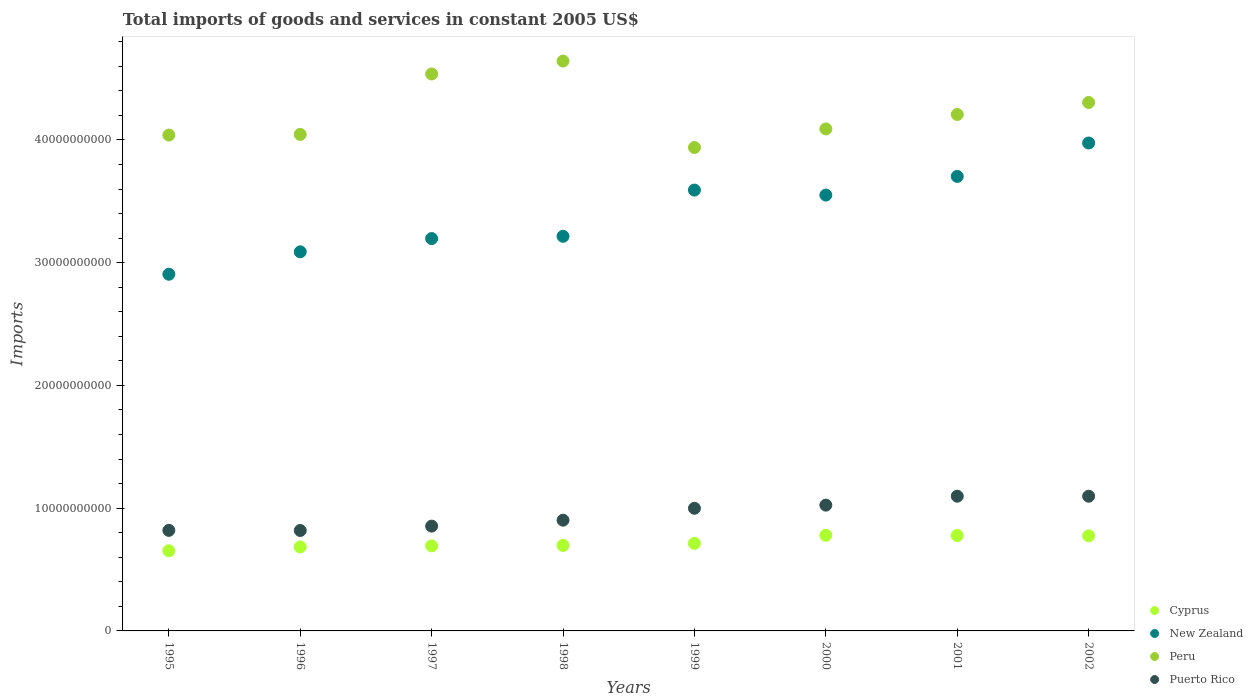How many different coloured dotlines are there?
Give a very brief answer. 4. Is the number of dotlines equal to the number of legend labels?
Keep it short and to the point. Yes. What is the total imports of goods and services in New Zealand in 1998?
Provide a short and direct response. 3.21e+1. Across all years, what is the maximum total imports of goods and services in Cyprus?
Keep it short and to the point. 7.79e+09. Across all years, what is the minimum total imports of goods and services in Peru?
Offer a very short reply. 3.94e+1. What is the total total imports of goods and services in Cyprus in the graph?
Make the answer very short. 5.77e+1. What is the difference between the total imports of goods and services in Cyprus in 1997 and that in 2001?
Give a very brief answer. -8.48e+08. What is the difference between the total imports of goods and services in Cyprus in 2002 and the total imports of goods and services in Puerto Rico in 1995?
Ensure brevity in your answer.  -4.43e+08. What is the average total imports of goods and services in Cyprus per year?
Provide a short and direct response. 7.21e+09. In the year 1997, what is the difference between the total imports of goods and services in Cyprus and total imports of goods and services in Peru?
Provide a short and direct response. -3.84e+1. In how many years, is the total imports of goods and services in New Zealand greater than 26000000000 US$?
Give a very brief answer. 8. What is the ratio of the total imports of goods and services in Cyprus in 1999 to that in 2000?
Give a very brief answer. 0.92. Is the total imports of goods and services in Peru in 1995 less than that in 1999?
Offer a terse response. No. What is the difference between the highest and the second highest total imports of goods and services in Puerto Rico?
Give a very brief answer. 5.59e+05. What is the difference between the highest and the lowest total imports of goods and services in Peru?
Keep it short and to the point. 7.04e+09. Is the sum of the total imports of goods and services in New Zealand in 1998 and 2000 greater than the maximum total imports of goods and services in Cyprus across all years?
Keep it short and to the point. Yes. Is it the case that in every year, the sum of the total imports of goods and services in Cyprus and total imports of goods and services in Puerto Rico  is greater than the total imports of goods and services in New Zealand?
Offer a very short reply. No. Does the total imports of goods and services in Peru monotonically increase over the years?
Offer a terse response. No. Is the total imports of goods and services in Puerto Rico strictly less than the total imports of goods and services in New Zealand over the years?
Give a very brief answer. Yes. How many dotlines are there?
Your answer should be very brief. 4. What is the difference between two consecutive major ticks on the Y-axis?
Give a very brief answer. 1.00e+1. Where does the legend appear in the graph?
Your answer should be compact. Bottom right. How many legend labels are there?
Give a very brief answer. 4. What is the title of the graph?
Offer a terse response. Total imports of goods and services in constant 2005 US$. What is the label or title of the Y-axis?
Make the answer very short. Imports. What is the Imports in Cyprus in 1995?
Ensure brevity in your answer.  6.53e+09. What is the Imports of New Zealand in 1995?
Offer a terse response. 2.91e+1. What is the Imports in Peru in 1995?
Make the answer very short. 4.04e+1. What is the Imports of Puerto Rico in 1995?
Your answer should be very brief. 8.19e+09. What is the Imports of Cyprus in 1996?
Provide a short and direct response. 6.84e+09. What is the Imports in New Zealand in 1996?
Your answer should be compact. 3.09e+1. What is the Imports in Peru in 1996?
Offer a terse response. 4.04e+1. What is the Imports of Puerto Rico in 1996?
Your response must be concise. 8.18e+09. What is the Imports of Cyprus in 1997?
Offer a very short reply. 6.93e+09. What is the Imports in New Zealand in 1997?
Make the answer very short. 3.20e+1. What is the Imports of Peru in 1997?
Offer a very short reply. 4.54e+1. What is the Imports in Puerto Rico in 1997?
Provide a succinct answer. 8.54e+09. What is the Imports in Cyprus in 1998?
Keep it short and to the point. 6.96e+09. What is the Imports in New Zealand in 1998?
Your answer should be compact. 3.21e+1. What is the Imports of Peru in 1998?
Make the answer very short. 4.64e+1. What is the Imports of Puerto Rico in 1998?
Give a very brief answer. 9.02e+09. What is the Imports in Cyprus in 1999?
Offer a terse response. 7.13e+09. What is the Imports in New Zealand in 1999?
Keep it short and to the point. 3.59e+1. What is the Imports in Peru in 1999?
Keep it short and to the point. 3.94e+1. What is the Imports in Puerto Rico in 1999?
Provide a short and direct response. 9.99e+09. What is the Imports of Cyprus in 2000?
Give a very brief answer. 7.79e+09. What is the Imports of New Zealand in 2000?
Make the answer very short. 3.55e+1. What is the Imports in Peru in 2000?
Your answer should be very brief. 4.09e+1. What is the Imports of Puerto Rico in 2000?
Provide a short and direct response. 1.02e+1. What is the Imports of Cyprus in 2001?
Offer a terse response. 7.78e+09. What is the Imports of New Zealand in 2001?
Keep it short and to the point. 3.70e+1. What is the Imports of Peru in 2001?
Your answer should be compact. 4.21e+1. What is the Imports of Puerto Rico in 2001?
Give a very brief answer. 1.10e+1. What is the Imports in Cyprus in 2002?
Your answer should be compact. 7.75e+09. What is the Imports of New Zealand in 2002?
Your response must be concise. 3.97e+1. What is the Imports in Peru in 2002?
Your answer should be very brief. 4.30e+1. What is the Imports of Puerto Rico in 2002?
Your answer should be very brief. 1.10e+1. Across all years, what is the maximum Imports of Cyprus?
Provide a succinct answer. 7.79e+09. Across all years, what is the maximum Imports in New Zealand?
Offer a very short reply. 3.97e+1. Across all years, what is the maximum Imports of Peru?
Your answer should be compact. 4.64e+1. Across all years, what is the maximum Imports of Puerto Rico?
Give a very brief answer. 1.10e+1. Across all years, what is the minimum Imports of Cyprus?
Your response must be concise. 6.53e+09. Across all years, what is the minimum Imports of New Zealand?
Your answer should be very brief. 2.91e+1. Across all years, what is the minimum Imports in Peru?
Provide a succinct answer. 3.94e+1. Across all years, what is the minimum Imports in Puerto Rico?
Keep it short and to the point. 8.18e+09. What is the total Imports in Cyprus in the graph?
Keep it short and to the point. 5.77e+1. What is the total Imports in New Zealand in the graph?
Offer a very short reply. 2.72e+11. What is the total Imports of Peru in the graph?
Offer a terse response. 3.38e+11. What is the total Imports in Puerto Rico in the graph?
Offer a very short reply. 7.61e+1. What is the difference between the Imports in Cyprus in 1995 and that in 1996?
Make the answer very short. -3.12e+08. What is the difference between the Imports of New Zealand in 1995 and that in 1996?
Provide a succinct answer. -1.83e+09. What is the difference between the Imports of Peru in 1995 and that in 1996?
Offer a very short reply. -5.37e+07. What is the difference between the Imports of Puerto Rico in 1995 and that in 1996?
Keep it short and to the point. 9.22e+06. What is the difference between the Imports in Cyprus in 1995 and that in 1997?
Your answer should be compact. -3.96e+08. What is the difference between the Imports in New Zealand in 1995 and that in 1997?
Your response must be concise. -2.91e+09. What is the difference between the Imports of Peru in 1995 and that in 1997?
Your response must be concise. -4.97e+09. What is the difference between the Imports of Puerto Rico in 1995 and that in 1997?
Make the answer very short. -3.47e+08. What is the difference between the Imports of Cyprus in 1995 and that in 1998?
Your answer should be very brief. -4.33e+08. What is the difference between the Imports in New Zealand in 1995 and that in 1998?
Keep it short and to the point. -3.09e+09. What is the difference between the Imports in Peru in 1995 and that in 1998?
Offer a terse response. -6.03e+09. What is the difference between the Imports in Puerto Rico in 1995 and that in 1998?
Give a very brief answer. -8.31e+08. What is the difference between the Imports in Cyprus in 1995 and that in 1999?
Ensure brevity in your answer.  -6.02e+08. What is the difference between the Imports in New Zealand in 1995 and that in 1999?
Offer a terse response. -6.86e+09. What is the difference between the Imports of Peru in 1995 and that in 1999?
Provide a short and direct response. 1.01e+09. What is the difference between the Imports in Puerto Rico in 1995 and that in 1999?
Ensure brevity in your answer.  -1.80e+09. What is the difference between the Imports of Cyprus in 1995 and that in 2000?
Offer a very short reply. -1.26e+09. What is the difference between the Imports in New Zealand in 1995 and that in 2000?
Offer a terse response. -6.45e+09. What is the difference between the Imports in Peru in 1995 and that in 2000?
Provide a succinct answer. -4.97e+08. What is the difference between the Imports of Puerto Rico in 1995 and that in 2000?
Your answer should be compact. -2.06e+09. What is the difference between the Imports of Cyprus in 1995 and that in 2001?
Provide a succinct answer. -1.24e+09. What is the difference between the Imports in New Zealand in 1995 and that in 2001?
Offer a very short reply. -7.97e+09. What is the difference between the Imports in Peru in 1995 and that in 2001?
Give a very brief answer. -1.68e+09. What is the difference between the Imports of Puerto Rico in 1995 and that in 2001?
Ensure brevity in your answer.  -2.78e+09. What is the difference between the Imports in Cyprus in 1995 and that in 2002?
Your response must be concise. -1.22e+09. What is the difference between the Imports in New Zealand in 1995 and that in 2002?
Give a very brief answer. -1.07e+1. What is the difference between the Imports in Peru in 1995 and that in 2002?
Provide a succinct answer. -2.65e+09. What is the difference between the Imports in Puerto Rico in 1995 and that in 2002?
Provide a succinct answer. -2.78e+09. What is the difference between the Imports in Cyprus in 1996 and that in 1997?
Make the answer very short. -8.42e+07. What is the difference between the Imports of New Zealand in 1996 and that in 1997?
Give a very brief answer. -1.08e+09. What is the difference between the Imports of Peru in 1996 and that in 1997?
Make the answer very short. -4.92e+09. What is the difference between the Imports of Puerto Rico in 1996 and that in 1997?
Keep it short and to the point. -3.56e+08. What is the difference between the Imports in Cyprus in 1996 and that in 1998?
Offer a very short reply. -1.21e+08. What is the difference between the Imports of New Zealand in 1996 and that in 1998?
Your answer should be very brief. -1.26e+09. What is the difference between the Imports in Peru in 1996 and that in 1998?
Keep it short and to the point. -5.97e+09. What is the difference between the Imports in Puerto Rico in 1996 and that in 1998?
Your response must be concise. -8.40e+08. What is the difference between the Imports of Cyprus in 1996 and that in 1999?
Give a very brief answer. -2.90e+08. What is the difference between the Imports of New Zealand in 1996 and that in 1999?
Give a very brief answer. -5.03e+09. What is the difference between the Imports of Peru in 1996 and that in 1999?
Keep it short and to the point. 1.07e+09. What is the difference between the Imports of Puerto Rico in 1996 and that in 1999?
Your answer should be compact. -1.81e+09. What is the difference between the Imports in Cyprus in 1996 and that in 2000?
Offer a terse response. -9.48e+08. What is the difference between the Imports of New Zealand in 1996 and that in 2000?
Provide a short and direct response. -4.62e+09. What is the difference between the Imports of Peru in 1996 and that in 2000?
Your answer should be compact. -4.43e+08. What is the difference between the Imports in Puerto Rico in 1996 and that in 2000?
Provide a succinct answer. -2.07e+09. What is the difference between the Imports in Cyprus in 1996 and that in 2001?
Offer a very short reply. -9.33e+08. What is the difference between the Imports of New Zealand in 1996 and that in 2001?
Make the answer very short. -6.14e+09. What is the difference between the Imports in Peru in 1996 and that in 2001?
Give a very brief answer. -1.62e+09. What is the difference between the Imports of Puerto Rico in 1996 and that in 2001?
Give a very brief answer. -2.79e+09. What is the difference between the Imports of Cyprus in 1996 and that in 2002?
Your response must be concise. -9.05e+08. What is the difference between the Imports in New Zealand in 1996 and that in 2002?
Ensure brevity in your answer.  -8.86e+09. What is the difference between the Imports in Peru in 1996 and that in 2002?
Your answer should be compact. -2.60e+09. What is the difference between the Imports in Puerto Rico in 1996 and that in 2002?
Give a very brief answer. -2.79e+09. What is the difference between the Imports in Cyprus in 1997 and that in 1998?
Your response must be concise. -3.70e+07. What is the difference between the Imports in New Zealand in 1997 and that in 1998?
Provide a succinct answer. -1.84e+08. What is the difference between the Imports in Peru in 1997 and that in 1998?
Offer a terse response. -1.05e+09. What is the difference between the Imports of Puerto Rico in 1997 and that in 1998?
Give a very brief answer. -4.84e+08. What is the difference between the Imports of Cyprus in 1997 and that in 1999?
Provide a short and direct response. -2.06e+08. What is the difference between the Imports of New Zealand in 1997 and that in 1999?
Keep it short and to the point. -3.95e+09. What is the difference between the Imports in Peru in 1997 and that in 1999?
Give a very brief answer. 5.99e+09. What is the difference between the Imports in Puerto Rico in 1997 and that in 1999?
Ensure brevity in your answer.  -1.45e+09. What is the difference between the Imports of Cyprus in 1997 and that in 2000?
Your response must be concise. -8.63e+08. What is the difference between the Imports in New Zealand in 1997 and that in 2000?
Offer a terse response. -3.54e+09. What is the difference between the Imports in Peru in 1997 and that in 2000?
Your answer should be compact. 4.48e+09. What is the difference between the Imports in Puerto Rico in 1997 and that in 2000?
Offer a terse response. -1.71e+09. What is the difference between the Imports of Cyprus in 1997 and that in 2001?
Offer a very short reply. -8.48e+08. What is the difference between the Imports in New Zealand in 1997 and that in 2001?
Your response must be concise. -5.06e+09. What is the difference between the Imports of Peru in 1997 and that in 2001?
Your answer should be very brief. 3.30e+09. What is the difference between the Imports of Puerto Rico in 1997 and that in 2001?
Your answer should be very brief. -2.44e+09. What is the difference between the Imports in Cyprus in 1997 and that in 2002?
Your answer should be compact. -8.21e+08. What is the difference between the Imports of New Zealand in 1997 and that in 2002?
Provide a succinct answer. -7.78e+09. What is the difference between the Imports of Peru in 1997 and that in 2002?
Offer a terse response. 2.32e+09. What is the difference between the Imports of Puerto Rico in 1997 and that in 2002?
Offer a terse response. -2.44e+09. What is the difference between the Imports in Cyprus in 1998 and that in 1999?
Provide a succinct answer. -1.69e+08. What is the difference between the Imports of New Zealand in 1998 and that in 1999?
Ensure brevity in your answer.  -3.77e+09. What is the difference between the Imports in Peru in 1998 and that in 1999?
Give a very brief answer. 7.04e+09. What is the difference between the Imports in Puerto Rico in 1998 and that in 1999?
Provide a succinct answer. -9.69e+08. What is the difference between the Imports in Cyprus in 1998 and that in 2000?
Keep it short and to the point. -8.26e+08. What is the difference between the Imports of New Zealand in 1998 and that in 2000?
Give a very brief answer. -3.36e+09. What is the difference between the Imports of Peru in 1998 and that in 2000?
Provide a succinct answer. 5.53e+09. What is the difference between the Imports of Puerto Rico in 1998 and that in 2000?
Provide a succinct answer. -1.23e+09. What is the difference between the Imports of Cyprus in 1998 and that in 2001?
Ensure brevity in your answer.  -8.11e+08. What is the difference between the Imports in New Zealand in 1998 and that in 2001?
Your response must be concise. -4.88e+09. What is the difference between the Imports in Peru in 1998 and that in 2001?
Offer a terse response. 4.35e+09. What is the difference between the Imports of Puerto Rico in 1998 and that in 2001?
Make the answer very short. -1.95e+09. What is the difference between the Imports in Cyprus in 1998 and that in 2002?
Your response must be concise. -7.84e+08. What is the difference between the Imports of New Zealand in 1998 and that in 2002?
Provide a succinct answer. -7.60e+09. What is the difference between the Imports in Peru in 1998 and that in 2002?
Ensure brevity in your answer.  3.37e+09. What is the difference between the Imports of Puerto Rico in 1998 and that in 2002?
Offer a very short reply. -1.95e+09. What is the difference between the Imports in Cyprus in 1999 and that in 2000?
Offer a terse response. -6.57e+08. What is the difference between the Imports of New Zealand in 1999 and that in 2000?
Your answer should be compact. 4.07e+08. What is the difference between the Imports in Peru in 1999 and that in 2000?
Your response must be concise. -1.51e+09. What is the difference between the Imports in Puerto Rico in 1999 and that in 2000?
Your answer should be compact. -2.56e+08. What is the difference between the Imports of Cyprus in 1999 and that in 2001?
Offer a very short reply. -6.42e+08. What is the difference between the Imports of New Zealand in 1999 and that in 2001?
Provide a short and direct response. -1.11e+09. What is the difference between the Imports of Peru in 1999 and that in 2001?
Offer a terse response. -2.69e+09. What is the difference between the Imports of Puerto Rico in 1999 and that in 2001?
Your answer should be compact. -9.85e+08. What is the difference between the Imports of Cyprus in 1999 and that in 2002?
Ensure brevity in your answer.  -6.15e+08. What is the difference between the Imports in New Zealand in 1999 and that in 2002?
Your answer should be very brief. -3.83e+09. What is the difference between the Imports in Peru in 1999 and that in 2002?
Ensure brevity in your answer.  -3.67e+09. What is the difference between the Imports in Puerto Rico in 1999 and that in 2002?
Make the answer very short. -9.84e+08. What is the difference between the Imports in Cyprus in 2000 and that in 2001?
Your response must be concise. 1.49e+07. What is the difference between the Imports in New Zealand in 2000 and that in 2001?
Your answer should be very brief. -1.52e+09. What is the difference between the Imports of Peru in 2000 and that in 2001?
Your answer should be compact. -1.18e+09. What is the difference between the Imports in Puerto Rico in 2000 and that in 2001?
Keep it short and to the point. -7.28e+08. What is the difference between the Imports of Cyprus in 2000 and that in 2002?
Keep it short and to the point. 4.27e+07. What is the difference between the Imports in New Zealand in 2000 and that in 2002?
Keep it short and to the point. -4.24e+09. What is the difference between the Imports of Peru in 2000 and that in 2002?
Your response must be concise. -2.16e+09. What is the difference between the Imports in Puerto Rico in 2000 and that in 2002?
Make the answer very short. -7.27e+08. What is the difference between the Imports of Cyprus in 2001 and that in 2002?
Offer a very short reply. 2.78e+07. What is the difference between the Imports of New Zealand in 2001 and that in 2002?
Provide a short and direct response. -2.72e+09. What is the difference between the Imports of Peru in 2001 and that in 2002?
Make the answer very short. -9.76e+08. What is the difference between the Imports in Puerto Rico in 2001 and that in 2002?
Ensure brevity in your answer.  5.59e+05. What is the difference between the Imports of Cyprus in 1995 and the Imports of New Zealand in 1996?
Ensure brevity in your answer.  -2.44e+1. What is the difference between the Imports in Cyprus in 1995 and the Imports in Peru in 1996?
Give a very brief answer. -3.39e+1. What is the difference between the Imports of Cyprus in 1995 and the Imports of Puerto Rico in 1996?
Ensure brevity in your answer.  -1.65e+09. What is the difference between the Imports in New Zealand in 1995 and the Imports in Peru in 1996?
Your answer should be compact. -1.14e+1. What is the difference between the Imports in New Zealand in 1995 and the Imports in Puerto Rico in 1996?
Offer a very short reply. 2.09e+1. What is the difference between the Imports of Peru in 1995 and the Imports of Puerto Rico in 1996?
Keep it short and to the point. 3.22e+1. What is the difference between the Imports in Cyprus in 1995 and the Imports in New Zealand in 1997?
Ensure brevity in your answer.  -2.54e+1. What is the difference between the Imports of Cyprus in 1995 and the Imports of Peru in 1997?
Make the answer very short. -3.88e+1. What is the difference between the Imports of Cyprus in 1995 and the Imports of Puerto Rico in 1997?
Offer a very short reply. -2.01e+09. What is the difference between the Imports in New Zealand in 1995 and the Imports in Peru in 1997?
Ensure brevity in your answer.  -1.63e+1. What is the difference between the Imports in New Zealand in 1995 and the Imports in Puerto Rico in 1997?
Ensure brevity in your answer.  2.05e+1. What is the difference between the Imports in Peru in 1995 and the Imports in Puerto Rico in 1997?
Give a very brief answer. 3.19e+1. What is the difference between the Imports of Cyprus in 1995 and the Imports of New Zealand in 1998?
Your answer should be very brief. -2.56e+1. What is the difference between the Imports in Cyprus in 1995 and the Imports in Peru in 1998?
Your response must be concise. -3.99e+1. What is the difference between the Imports in Cyprus in 1995 and the Imports in Puerto Rico in 1998?
Make the answer very short. -2.49e+09. What is the difference between the Imports of New Zealand in 1995 and the Imports of Peru in 1998?
Make the answer very short. -1.74e+1. What is the difference between the Imports in New Zealand in 1995 and the Imports in Puerto Rico in 1998?
Your answer should be compact. 2.00e+1. What is the difference between the Imports of Peru in 1995 and the Imports of Puerto Rico in 1998?
Make the answer very short. 3.14e+1. What is the difference between the Imports of Cyprus in 1995 and the Imports of New Zealand in 1999?
Your answer should be compact. -2.94e+1. What is the difference between the Imports in Cyprus in 1995 and the Imports in Peru in 1999?
Make the answer very short. -3.29e+1. What is the difference between the Imports of Cyprus in 1995 and the Imports of Puerto Rico in 1999?
Ensure brevity in your answer.  -3.46e+09. What is the difference between the Imports in New Zealand in 1995 and the Imports in Peru in 1999?
Provide a succinct answer. -1.03e+1. What is the difference between the Imports of New Zealand in 1995 and the Imports of Puerto Rico in 1999?
Provide a short and direct response. 1.91e+1. What is the difference between the Imports in Peru in 1995 and the Imports in Puerto Rico in 1999?
Your response must be concise. 3.04e+1. What is the difference between the Imports in Cyprus in 1995 and the Imports in New Zealand in 2000?
Ensure brevity in your answer.  -2.90e+1. What is the difference between the Imports of Cyprus in 1995 and the Imports of Peru in 2000?
Ensure brevity in your answer.  -3.44e+1. What is the difference between the Imports in Cyprus in 1995 and the Imports in Puerto Rico in 2000?
Make the answer very short. -3.72e+09. What is the difference between the Imports of New Zealand in 1995 and the Imports of Peru in 2000?
Ensure brevity in your answer.  -1.18e+1. What is the difference between the Imports of New Zealand in 1995 and the Imports of Puerto Rico in 2000?
Ensure brevity in your answer.  1.88e+1. What is the difference between the Imports in Peru in 1995 and the Imports in Puerto Rico in 2000?
Make the answer very short. 3.01e+1. What is the difference between the Imports in Cyprus in 1995 and the Imports in New Zealand in 2001?
Offer a terse response. -3.05e+1. What is the difference between the Imports in Cyprus in 1995 and the Imports in Peru in 2001?
Your response must be concise. -3.55e+1. What is the difference between the Imports of Cyprus in 1995 and the Imports of Puerto Rico in 2001?
Your answer should be very brief. -4.44e+09. What is the difference between the Imports of New Zealand in 1995 and the Imports of Peru in 2001?
Offer a very short reply. -1.30e+1. What is the difference between the Imports of New Zealand in 1995 and the Imports of Puerto Rico in 2001?
Give a very brief answer. 1.81e+1. What is the difference between the Imports in Peru in 1995 and the Imports in Puerto Rico in 2001?
Keep it short and to the point. 2.94e+1. What is the difference between the Imports in Cyprus in 1995 and the Imports in New Zealand in 2002?
Keep it short and to the point. -3.32e+1. What is the difference between the Imports of Cyprus in 1995 and the Imports of Peru in 2002?
Offer a terse response. -3.65e+1. What is the difference between the Imports of Cyprus in 1995 and the Imports of Puerto Rico in 2002?
Offer a terse response. -4.44e+09. What is the difference between the Imports in New Zealand in 1995 and the Imports in Peru in 2002?
Your answer should be very brief. -1.40e+1. What is the difference between the Imports in New Zealand in 1995 and the Imports in Puerto Rico in 2002?
Keep it short and to the point. 1.81e+1. What is the difference between the Imports in Peru in 1995 and the Imports in Puerto Rico in 2002?
Make the answer very short. 2.94e+1. What is the difference between the Imports in Cyprus in 1996 and the Imports in New Zealand in 1997?
Offer a very short reply. -2.51e+1. What is the difference between the Imports in Cyprus in 1996 and the Imports in Peru in 1997?
Provide a succinct answer. -3.85e+1. What is the difference between the Imports of Cyprus in 1996 and the Imports of Puerto Rico in 1997?
Your response must be concise. -1.70e+09. What is the difference between the Imports of New Zealand in 1996 and the Imports of Peru in 1997?
Make the answer very short. -1.45e+1. What is the difference between the Imports in New Zealand in 1996 and the Imports in Puerto Rico in 1997?
Provide a succinct answer. 2.23e+1. What is the difference between the Imports of Peru in 1996 and the Imports of Puerto Rico in 1997?
Offer a terse response. 3.19e+1. What is the difference between the Imports in Cyprus in 1996 and the Imports in New Zealand in 1998?
Keep it short and to the point. -2.53e+1. What is the difference between the Imports in Cyprus in 1996 and the Imports in Peru in 1998?
Provide a short and direct response. -3.96e+1. What is the difference between the Imports of Cyprus in 1996 and the Imports of Puerto Rico in 1998?
Make the answer very short. -2.18e+09. What is the difference between the Imports of New Zealand in 1996 and the Imports of Peru in 1998?
Make the answer very short. -1.55e+1. What is the difference between the Imports of New Zealand in 1996 and the Imports of Puerto Rico in 1998?
Your response must be concise. 2.19e+1. What is the difference between the Imports in Peru in 1996 and the Imports in Puerto Rico in 1998?
Offer a terse response. 3.14e+1. What is the difference between the Imports of Cyprus in 1996 and the Imports of New Zealand in 1999?
Your answer should be compact. -2.91e+1. What is the difference between the Imports of Cyprus in 1996 and the Imports of Peru in 1999?
Provide a succinct answer. -3.25e+1. What is the difference between the Imports of Cyprus in 1996 and the Imports of Puerto Rico in 1999?
Provide a succinct answer. -3.15e+09. What is the difference between the Imports in New Zealand in 1996 and the Imports in Peru in 1999?
Your response must be concise. -8.50e+09. What is the difference between the Imports of New Zealand in 1996 and the Imports of Puerto Rico in 1999?
Your response must be concise. 2.09e+1. What is the difference between the Imports of Peru in 1996 and the Imports of Puerto Rico in 1999?
Give a very brief answer. 3.05e+1. What is the difference between the Imports of Cyprus in 1996 and the Imports of New Zealand in 2000?
Provide a succinct answer. -2.87e+1. What is the difference between the Imports of Cyprus in 1996 and the Imports of Peru in 2000?
Ensure brevity in your answer.  -3.41e+1. What is the difference between the Imports of Cyprus in 1996 and the Imports of Puerto Rico in 2000?
Provide a short and direct response. -3.40e+09. What is the difference between the Imports of New Zealand in 1996 and the Imports of Peru in 2000?
Provide a short and direct response. -1.00e+1. What is the difference between the Imports of New Zealand in 1996 and the Imports of Puerto Rico in 2000?
Ensure brevity in your answer.  2.06e+1. What is the difference between the Imports in Peru in 1996 and the Imports in Puerto Rico in 2000?
Your response must be concise. 3.02e+1. What is the difference between the Imports of Cyprus in 1996 and the Imports of New Zealand in 2001?
Your response must be concise. -3.02e+1. What is the difference between the Imports in Cyprus in 1996 and the Imports in Peru in 2001?
Make the answer very short. -3.52e+1. What is the difference between the Imports in Cyprus in 1996 and the Imports in Puerto Rico in 2001?
Offer a very short reply. -4.13e+09. What is the difference between the Imports of New Zealand in 1996 and the Imports of Peru in 2001?
Provide a succinct answer. -1.12e+1. What is the difference between the Imports in New Zealand in 1996 and the Imports in Puerto Rico in 2001?
Your answer should be very brief. 1.99e+1. What is the difference between the Imports of Peru in 1996 and the Imports of Puerto Rico in 2001?
Make the answer very short. 2.95e+1. What is the difference between the Imports in Cyprus in 1996 and the Imports in New Zealand in 2002?
Your answer should be very brief. -3.29e+1. What is the difference between the Imports in Cyprus in 1996 and the Imports in Peru in 2002?
Provide a short and direct response. -3.62e+1. What is the difference between the Imports in Cyprus in 1996 and the Imports in Puerto Rico in 2002?
Offer a very short reply. -4.13e+09. What is the difference between the Imports in New Zealand in 1996 and the Imports in Peru in 2002?
Offer a very short reply. -1.22e+1. What is the difference between the Imports of New Zealand in 1996 and the Imports of Puerto Rico in 2002?
Ensure brevity in your answer.  1.99e+1. What is the difference between the Imports in Peru in 1996 and the Imports in Puerto Rico in 2002?
Give a very brief answer. 2.95e+1. What is the difference between the Imports of Cyprus in 1997 and the Imports of New Zealand in 1998?
Make the answer very short. -2.52e+1. What is the difference between the Imports of Cyprus in 1997 and the Imports of Peru in 1998?
Ensure brevity in your answer.  -3.95e+1. What is the difference between the Imports in Cyprus in 1997 and the Imports in Puerto Rico in 1998?
Offer a very short reply. -2.10e+09. What is the difference between the Imports in New Zealand in 1997 and the Imports in Peru in 1998?
Your answer should be very brief. -1.45e+1. What is the difference between the Imports of New Zealand in 1997 and the Imports of Puerto Rico in 1998?
Offer a very short reply. 2.29e+1. What is the difference between the Imports of Peru in 1997 and the Imports of Puerto Rico in 1998?
Provide a short and direct response. 3.63e+1. What is the difference between the Imports of Cyprus in 1997 and the Imports of New Zealand in 1999?
Your answer should be very brief. -2.90e+1. What is the difference between the Imports in Cyprus in 1997 and the Imports in Peru in 1999?
Ensure brevity in your answer.  -3.25e+1. What is the difference between the Imports of Cyprus in 1997 and the Imports of Puerto Rico in 1999?
Make the answer very short. -3.06e+09. What is the difference between the Imports in New Zealand in 1997 and the Imports in Peru in 1999?
Give a very brief answer. -7.42e+09. What is the difference between the Imports in New Zealand in 1997 and the Imports in Puerto Rico in 1999?
Your answer should be compact. 2.20e+1. What is the difference between the Imports in Peru in 1997 and the Imports in Puerto Rico in 1999?
Offer a very short reply. 3.54e+1. What is the difference between the Imports of Cyprus in 1997 and the Imports of New Zealand in 2000?
Provide a short and direct response. -2.86e+1. What is the difference between the Imports in Cyprus in 1997 and the Imports in Peru in 2000?
Offer a very short reply. -3.40e+1. What is the difference between the Imports in Cyprus in 1997 and the Imports in Puerto Rico in 2000?
Offer a very short reply. -3.32e+09. What is the difference between the Imports of New Zealand in 1997 and the Imports of Peru in 2000?
Provide a succinct answer. -8.93e+09. What is the difference between the Imports in New Zealand in 1997 and the Imports in Puerto Rico in 2000?
Keep it short and to the point. 2.17e+1. What is the difference between the Imports of Peru in 1997 and the Imports of Puerto Rico in 2000?
Your answer should be very brief. 3.51e+1. What is the difference between the Imports in Cyprus in 1997 and the Imports in New Zealand in 2001?
Provide a short and direct response. -3.01e+1. What is the difference between the Imports of Cyprus in 1997 and the Imports of Peru in 2001?
Your answer should be compact. -3.51e+1. What is the difference between the Imports of Cyprus in 1997 and the Imports of Puerto Rico in 2001?
Provide a succinct answer. -4.05e+09. What is the difference between the Imports of New Zealand in 1997 and the Imports of Peru in 2001?
Provide a succinct answer. -1.01e+1. What is the difference between the Imports in New Zealand in 1997 and the Imports in Puerto Rico in 2001?
Your answer should be very brief. 2.10e+1. What is the difference between the Imports in Peru in 1997 and the Imports in Puerto Rico in 2001?
Your answer should be very brief. 3.44e+1. What is the difference between the Imports in Cyprus in 1997 and the Imports in New Zealand in 2002?
Offer a very short reply. -3.28e+1. What is the difference between the Imports in Cyprus in 1997 and the Imports in Peru in 2002?
Offer a terse response. -3.61e+1. What is the difference between the Imports of Cyprus in 1997 and the Imports of Puerto Rico in 2002?
Your answer should be compact. -4.05e+09. What is the difference between the Imports in New Zealand in 1997 and the Imports in Peru in 2002?
Ensure brevity in your answer.  -1.11e+1. What is the difference between the Imports in New Zealand in 1997 and the Imports in Puerto Rico in 2002?
Provide a short and direct response. 2.10e+1. What is the difference between the Imports in Peru in 1997 and the Imports in Puerto Rico in 2002?
Give a very brief answer. 3.44e+1. What is the difference between the Imports of Cyprus in 1998 and the Imports of New Zealand in 1999?
Make the answer very short. -2.89e+1. What is the difference between the Imports of Cyprus in 1998 and the Imports of Peru in 1999?
Make the answer very short. -3.24e+1. What is the difference between the Imports in Cyprus in 1998 and the Imports in Puerto Rico in 1999?
Keep it short and to the point. -3.03e+09. What is the difference between the Imports of New Zealand in 1998 and the Imports of Peru in 1999?
Ensure brevity in your answer.  -7.23e+09. What is the difference between the Imports of New Zealand in 1998 and the Imports of Puerto Rico in 1999?
Provide a short and direct response. 2.22e+1. What is the difference between the Imports of Peru in 1998 and the Imports of Puerto Rico in 1999?
Your answer should be very brief. 3.64e+1. What is the difference between the Imports of Cyprus in 1998 and the Imports of New Zealand in 2000?
Give a very brief answer. -2.85e+1. What is the difference between the Imports of Cyprus in 1998 and the Imports of Peru in 2000?
Provide a succinct answer. -3.39e+1. What is the difference between the Imports of Cyprus in 1998 and the Imports of Puerto Rico in 2000?
Offer a terse response. -3.28e+09. What is the difference between the Imports in New Zealand in 1998 and the Imports in Peru in 2000?
Make the answer very short. -8.75e+09. What is the difference between the Imports of New Zealand in 1998 and the Imports of Puerto Rico in 2000?
Provide a succinct answer. 2.19e+1. What is the difference between the Imports in Peru in 1998 and the Imports in Puerto Rico in 2000?
Provide a short and direct response. 3.62e+1. What is the difference between the Imports in Cyprus in 1998 and the Imports in New Zealand in 2001?
Offer a very short reply. -3.01e+1. What is the difference between the Imports of Cyprus in 1998 and the Imports of Peru in 2001?
Provide a succinct answer. -3.51e+1. What is the difference between the Imports in Cyprus in 1998 and the Imports in Puerto Rico in 2001?
Make the answer very short. -4.01e+09. What is the difference between the Imports of New Zealand in 1998 and the Imports of Peru in 2001?
Offer a terse response. -9.93e+09. What is the difference between the Imports in New Zealand in 1998 and the Imports in Puerto Rico in 2001?
Your answer should be very brief. 2.12e+1. What is the difference between the Imports in Peru in 1998 and the Imports in Puerto Rico in 2001?
Offer a terse response. 3.54e+1. What is the difference between the Imports in Cyprus in 1998 and the Imports in New Zealand in 2002?
Ensure brevity in your answer.  -3.28e+1. What is the difference between the Imports of Cyprus in 1998 and the Imports of Peru in 2002?
Provide a short and direct response. -3.61e+1. What is the difference between the Imports of Cyprus in 1998 and the Imports of Puerto Rico in 2002?
Give a very brief answer. -4.01e+09. What is the difference between the Imports of New Zealand in 1998 and the Imports of Peru in 2002?
Provide a short and direct response. -1.09e+1. What is the difference between the Imports of New Zealand in 1998 and the Imports of Puerto Rico in 2002?
Provide a succinct answer. 2.12e+1. What is the difference between the Imports in Peru in 1998 and the Imports in Puerto Rico in 2002?
Your answer should be compact. 3.54e+1. What is the difference between the Imports of Cyprus in 1999 and the Imports of New Zealand in 2000?
Give a very brief answer. -2.84e+1. What is the difference between the Imports in Cyprus in 1999 and the Imports in Peru in 2000?
Offer a terse response. -3.38e+1. What is the difference between the Imports of Cyprus in 1999 and the Imports of Puerto Rico in 2000?
Provide a succinct answer. -3.11e+09. What is the difference between the Imports of New Zealand in 1999 and the Imports of Peru in 2000?
Give a very brief answer. -4.98e+09. What is the difference between the Imports in New Zealand in 1999 and the Imports in Puerto Rico in 2000?
Your answer should be compact. 2.57e+1. What is the difference between the Imports of Peru in 1999 and the Imports of Puerto Rico in 2000?
Your answer should be very brief. 2.91e+1. What is the difference between the Imports in Cyprus in 1999 and the Imports in New Zealand in 2001?
Ensure brevity in your answer.  -2.99e+1. What is the difference between the Imports of Cyprus in 1999 and the Imports of Peru in 2001?
Offer a terse response. -3.49e+1. What is the difference between the Imports of Cyprus in 1999 and the Imports of Puerto Rico in 2001?
Give a very brief answer. -3.84e+09. What is the difference between the Imports in New Zealand in 1999 and the Imports in Peru in 2001?
Provide a short and direct response. -6.16e+09. What is the difference between the Imports of New Zealand in 1999 and the Imports of Puerto Rico in 2001?
Keep it short and to the point. 2.49e+1. What is the difference between the Imports of Peru in 1999 and the Imports of Puerto Rico in 2001?
Offer a terse response. 2.84e+1. What is the difference between the Imports in Cyprus in 1999 and the Imports in New Zealand in 2002?
Make the answer very short. -3.26e+1. What is the difference between the Imports in Cyprus in 1999 and the Imports in Peru in 2002?
Offer a terse response. -3.59e+1. What is the difference between the Imports of Cyprus in 1999 and the Imports of Puerto Rico in 2002?
Your answer should be compact. -3.84e+09. What is the difference between the Imports in New Zealand in 1999 and the Imports in Peru in 2002?
Give a very brief answer. -7.14e+09. What is the difference between the Imports in New Zealand in 1999 and the Imports in Puerto Rico in 2002?
Make the answer very short. 2.49e+1. What is the difference between the Imports of Peru in 1999 and the Imports of Puerto Rico in 2002?
Your answer should be compact. 2.84e+1. What is the difference between the Imports of Cyprus in 2000 and the Imports of New Zealand in 2001?
Ensure brevity in your answer.  -2.92e+1. What is the difference between the Imports of Cyprus in 2000 and the Imports of Peru in 2001?
Offer a very short reply. -3.43e+1. What is the difference between the Imports in Cyprus in 2000 and the Imports in Puerto Rico in 2001?
Ensure brevity in your answer.  -3.19e+09. What is the difference between the Imports in New Zealand in 2000 and the Imports in Peru in 2001?
Give a very brief answer. -6.57e+09. What is the difference between the Imports of New Zealand in 2000 and the Imports of Puerto Rico in 2001?
Give a very brief answer. 2.45e+1. What is the difference between the Imports of Peru in 2000 and the Imports of Puerto Rico in 2001?
Give a very brief answer. 2.99e+1. What is the difference between the Imports of Cyprus in 2000 and the Imports of New Zealand in 2002?
Your response must be concise. -3.20e+1. What is the difference between the Imports of Cyprus in 2000 and the Imports of Peru in 2002?
Give a very brief answer. -3.53e+1. What is the difference between the Imports in Cyprus in 2000 and the Imports in Puerto Rico in 2002?
Give a very brief answer. -3.18e+09. What is the difference between the Imports of New Zealand in 2000 and the Imports of Peru in 2002?
Make the answer very short. -7.54e+09. What is the difference between the Imports of New Zealand in 2000 and the Imports of Puerto Rico in 2002?
Offer a very short reply. 2.45e+1. What is the difference between the Imports in Peru in 2000 and the Imports in Puerto Rico in 2002?
Give a very brief answer. 2.99e+1. What is the difference between the Imports in Cyprus in 2001 and the Imports in New Zealand in 2002?
Offer a very short reply. -3.20e+1. What is the difference between the Imports in Cyprus in 2001 and the Imports in Peru in 2002?
Your answer should be very brief. -3.53e+1. What is the difference between the Imports in Cyprus in 2001 and the Imports in Puerto Rico in 2002?
Keep it short and to the point. -3.20e+09. What is the difference between the Imports of New Zealand in 2001 and the Imports of Peru in 2002?
Your response must be concise. -6.02e+09. What is the difference between the Imports in New Zealand in 2001 and the Imports in Puerto Rico in 2002?
Offer a terse response. 2.61e+1. What is the difference between the Imports in Peru in 2001 and the Imports in Puerto Rico in 2002?
Provide a short and direct response. 3.11e+1. What is the average Imports in Cyprus per year?
Make the answer very short. 7.21e+09. What is the average Imports in New Zealand per year?
Make the answer very short. 3.40e+1. What is the average Imports in Peru per year?
Give a very brief answer. 4.23e+1. What is the average Imports of Puerto Rico per year?
Provide a succinct answer. 9.52e+09. In the year 1995, what is the difference between the Imports in Cyprus and Imports in New Zealand?
Ensure brevity in your answer.  -2.25e+1. In the year 1995, what is the difference between the Imports in Cyprus and Imports in Peru?
Ensure brevity in your answer.  -3.39e+1. In the year 1995, what is the difference between the Imports of Cyprus and Imports of Puerto Rico?
Offer a terse response. -1.66e+09. In the year 1995, what is the difference between the Imports in New Zealand and Imports in Peru?
Provide a succinct answer. -1.13e+1. In the year 1995, what is the difference between the Imports of New Zealand and Imports of Puerto Rico?
Provide a succinct answer. 2.09e+1. In the year 1995, what is the difference between the Imports in Peru and Imports in Puerto Rico?
Make the answer very short. 3.22e+1. In the year 1996, what is the difference between the Imports of Cyprus and Imports of New Zealand?
Your answer should be compact. -2.40e+1. In the year 1996, what is the difference between the Imports in Cyprus and Imports in Peru?
Provide a short and direct response. -3.36e+1. In the year 1996, what is the difference between the Imports in Cyprus and Imports in Puerto Rico?
Keep it short and to the point. -1.34e+09. In the year 1996, what is the difference between the Imports in New Zealand and Imports in Peru?
Your answer should be very brief. -9.57e+09. In the year 1996, what is the difference between the Imports of New Zealand and Imports of Puerto Rico?
Provide a short and direct response. 2.27e+1. In the year 1996, what is the difference between the Imports in Peru and Imports in Puerto Rico?
Keep it short and to the point. 3.23e+1. In the year 1997, what is the difference between the Imports of Cyprus and Imports of New Zealand?
Your answer should be compact. -2.50e+1. In the year 1997, what is the difference between the Imports of Cyprus and Imports of Peru?
Ensure brevity in your answer.  -3.84e+1. In the year 1997, what is the difference between the Imports in Cyprus and Imports in Puerto Rico?
Offer a very short reply. -1.61e+09. In the year 1997, what is the difference between the Imports in New Zealand and Imports in Peru?
Provide a succinct answer. -1.34e+1. In the year 1997, what is the difference between the Imports in New Zealand and Imports in Puerto Rico?
Provide a short and direct response. 2.34e+1. In the year 1997, what is the difference between the Imports in Peru and Imports in Puerto Rico?
Your answer should be compact. 3.68e+1. In the year 1998, what is the difference between the Imports in Cyprus and Imports in New Zealand?
Give a very brief answer. -2.52e+1. In the year 1998, what is the difference between the Imports in Cyprus and Imports in Peru?
Offer a very short reply. -3.95e+1. In the year 1998, what is the difference between the Imports in Cyprus and Imports in Puerto Rico?
Provide a succinct answer. -2.06e+09. In the year 1998, what is the difference between the Imports in New Zealand and Imports in Peru?
Your answer should be compact. -1.43e+1. In the year 1998, what is the difference between the Imports in New Zealand and Imports in Puerto Rico?
Your answer should be very brief. 2.31e+1. In the year 1998, what is the difference between the Imports of Peru and Imports of Puerto Rico?
Ensure brevity in your answer.  3.74e+1. In the year 1999, what is the difference between the Imports of Cyprus and Imports of New Zealand?
Your answer should be compact. -2.88e+1. In the year 1999, what is the difference between the Imports in Cyprus and Imports in Peru?
Provide a succinct answer. -3.22e+1. In the year 1999, what is the difference between the Imports of Cyprus and Imports of Puerto Rico?
Offer a terse response. -2.86e+09. In the year 1999, what is the difference between the Imports in New Zealand and Imports in Peru?
Your answer should be compact. -3.47e+09. In the year 1999, what is the difference between the Imports in New Zealand and Imports in Puerto Rico?
Keep it short and to the point. 2.59e+1. In the year 1999, what is the difference between the Imports in Peru and Imports in Puerto Rico?
Ensure brevity in your answer.  2.94e+1. In the year 2000, what is the difference between the Imports of Cyprus and Imports of New Zealand?
Your answer should be very brief. -2.77e+1. In the year 2000, what is the difference between the Imports of Cyprus and Imports of Peru?
Make the answer very short. -3.31e+1. In the year 2000, what is the difference between the Imports of Cyprus and Imports of Puerto Rico?
Offer a terse response. -2.46e+09. In the year 2000, what is the difference between the Imports of New Zealand and Imports of Peru?
Provide a short and direct response. -5.39e+09. In the year 2000, what is the difference between the Imports in New Zealand and Imports in Puerto Rico?
Offer a very short reply. 2.53e+1. In the year 2000, what is the difference between the Imports in Peru and Imports in Puerto Rico?
Your response must be concise. 3.06e+1. In the year 2001, what is the difference between the Imports of Cyprus and Imports of New Zealand?
Keep it short and to the point. -2.93e+1. In the year 2001, what is the difference between the Imports of Cyprus and Imports of Peru?
Your response must be concise. -3.43e+1. In the year 2001, what is the difference between the Imports in Cyprus and Imports in Puerto Rico?
Your response must be concise. -3.20e+09. In the year 2001, what is the difference between the Imports of New Zealand and Imports of Peru?
Your answer should be compact. -5.05e+09. In the year 2001, what is the difference between the Imports in New Zealand and Imports in Puerto Rico?
Your answer should be compact. 2.61e+1. In the year 2001, what is the difference between the Imports of Peru and Imports of Puerto Rico?
Offer a very short reply. 3.11e+1. In the year 2002, what is the difference between the Imports in Cyprus and Imports in New Zealand?
Provide a short and direct response. -3.20e+1. In the year 2002, what is the difference between the Imports of Cyprus and Imports of Peru?
Your answer should be very brief. -3.53e+1. In the year 2002, what is the difference between the Imports of Cyprus and Imports of Puerto Rico?
Your answer should be very brief. -3.23e+09. In the year 2002, what is the difference between the Imports in New Zealand and Imports in Peru?
Provide a short and direct response. -3.30e+09. In the year 2002, what is the difference between the Imports in New Zealand and Imports in Puerto Rico?
Give a very brief answer. 2.88e+1. In the year 2002, what is the difference between the Imports of Peru and Imports of Puerto Rico?
Offer a terse response. 3.21e+1. What is the ratio of the Imports of Cyprus in 1995 to that in 1996?
Your answer should be very brief. 0.95. What is the ratio of the Imports in New Zealand in 1995 to that in 1996?
Your response must be concise. 0.94. What is the ratio of the Imports of Peru in 1995 to that in 1996?
Make the answer very short. 1. What is the ratio of the Imports of Puerto Rico in 1995 to that in 1996?
Offer a terse response. 1. What is the ratio of the Imports of Cyprus in 1995 to that in 1997?
Make the answer very short. 0.94. What is the ratio of the Imports of New Zealand in 1995 to that in 1997?
Ensure brevity in your answer.  0.91. What is the ratio of the Imports in Peru in 1995 to that in 1997?
Give a very brief answer. 0.89. What is the ratio of the Imports in Puerto Rico in 1995 to that in 1997?
Ensure brevity in your answer.  0.96. What is the ratio of the Imports of Cyprus in 1995 to that in 1998?
Offer a very short reply. 0.94. What is the ratio of the Imports in New Zealand in 1995 to that in 1998?
Your response must be concise. 0.9. What is the ratio of the Imports in Peru in 1995 to that in 1998?
Your answer should be very brief. 0.87. What is the ratio of the Imports in Puerto Rico in 1995 to that in 1998?
Offer a terse response. 0.91. What is the ratio of the Imports in Cyprus in 1995 to that in 1999?
Make the answer very short. 0.92. What is the ratio of the Imports of New Zealand in 1995 to that in 1999?
Make the answer very short. 0.81. What is the ratio of the Imports in Peru in 1995 to that in 1999?
Provide a succinct answer. 1.03. What is the ratio of the Imports in Puerto Rico in 1995 to that in 1999?
Make the answer very short. 0.82. What is the ratio of the Imports of Cyprus in 1995 to that in 2000?
Ensure brevity in your answer.  0.84. What is the ratio of the Imports in New Zealand in 1995 to that in 2000?
Give a very brief answer. 0.82. What is the ratio of the Imports in Puerto Rico in 1995 to that in 2000?
Ensure brevity in your answer.  0.8. What is the ratio of the Imports in Cyprus in 1995 to that in 2001?
Give a very brief answer. 0.84. What is the ratio of the Imports of New Zealand in 1995 to that in 2001?
Ensure brevity in your answer.  0.78. What is the ratio of the Imports in Peru in 1995 to that in 2001?
Your answer should be compact. 0.96. What is the ratio of the Imports in Puerto Rico in 1995 to that in 2001?
Provide a succinct answer. 0.75. What is the ratio of the Imports of Cyprus in 1995 to that in 2002?
Ensure brevity in your answer.  0.84. What is the ratio of the Imports of New Zealand in 1995 to that in 2002?
Make the answer very short. 0.73. What is the ratio of the Imports of Peru in 1995 to that in 2002?
Offer a terse response. 0.94. What is the ratio of the Imports in Puerto Rico in 1995 to that in 2002?
Offer a terse response. 0.75. What is the ratio of the Imports in New Zealand in 1996 to that in 1997?
Provide a succinct answer. 0.97. What is the ratio of the Imports of Peru in 1996 to that in 1997?
Your answer should be very brief. 0.89. What is the ratio of the Imports of Puerto Rico in 1996 to that in 1997?
Make the answer very short. 0.96. What is the ratio of the Imports of Cyprus in 1996 to that in 1998?
Your answer should be very brief. 0.98. What is the ratio of the Imports in New Zealand in 1996 to that in 1998?
Your response must be concise. 0.96. What is the ratio of the Imports of Peru in 1996 to that in 1998?
Offer a terse response. 0.87. What is the ratio of the Imports of Puerto Rico in 1996 to that in 1998?
Ensure brevity in your answer.  0.91. What is the ratio of the Imports of Cyprus in 1996 to that in 1999?
Give a very brief answer. 0.96. What is the ratio of the Imports of New Zealand in 1996 to that in 1999?
Offer a terse response. 0.86. What is the ratio of the Imports of Peru in 1996 to that in 1999?
Your answer should be compact. 1.03. What is the ratio of the Imports of Puerto Rico in 1996 to that in 1999?
Offer a very short reply. 0.82. What is the ratio of the Imports of Cyprus in 1996 to that in 2000?
Your answer should be compact. 0.88. What is the ratio of the Imports of New Zealand in 1996 to that in 2000?
Your answer should be very brief. 0.87. What is the ratio of the Imports of Peru in 1996 to that in 2000?
Offer a very short reply. 0.99. What is the ratio of the Imports in Puerto Rico in 1996 to that in 2000?
Make the answer very short. 0.8. What is the ratio of the Imports of New Zealand in 1996 to that in 2001?
Give a very brief answer. 0.83. What is the ratio of the Imports of Peru in 1996 to that in 2001?
Offer a terse response. 0.96. What is the ratio of the Imports in Puerto Rico in 1996 to that in 2001?
Your response must be concise. 0.75. What is the ratio of the Imports of Cyprus in 1996 to that in 2002?
Keep it short and to the point. 0.88. What is the ratio of the Imports in New Zealand in 1996 to that in 2002?
Make the answer very short. 0.78. What is the ratio of the Imports in Peru in 1996 to that in 2002?
Your response must be concise. 0.94. What is the ratio of the Imports in Puerto Rico in 1996 to that in 2002?
Your answer should be very brief. 0.75. What is the ratio of the Imports of Peru in 1997 to that in 1998?
Provide a short and direct response. 0.98. What is the ratio of the Imports in Puerto Rico in 1997 to that in 1998?
Your answer should be compact. 0.95. What is the ratio of the Imports in Cyprus in 1997 to that in 1999?
Keep it short and to the point. 0.97. What is the ratio of the Imports in New Zealand in 1997 to that in 1999?
Provide a succinct answer. 0.89. What is the ratio of the Imports in Peru in 1997 to that in 1999?
Give a very brief answer. 1.15. What is the ratio of the Imports in Puerto Rico in 1997 to that in 1999?
Your answer should be compact. 0.85. What is the ratio of the Imports in Cyprus in 1997 to that in 2000?
Give a very brief answer. 0.89. What is the ratio of the Imports in New Zealand in 1997 to that in 2000?
Keep it short and to the point. 0.9. What is the ratio of the Imports in Peru in 1997 to that in 2000?
Make the answer very short. 1.11. What is the ratio of the Imports in Puerto Rico in 1997 to that in 2000?
Provide a short and direct response. 0.83. What is the ratio of the Imports of Cyprus in 1997 to that in 2001?
Offer a very short reply. 0.89. What is the ratio of the Imports of New Zealand in 1997 to that in 2001?
Keep it short and to the point. 0.86. What is the ratio of the Imports of Peru in 1997 to that in 2001?
Make the answer very short. 1.08. What is the ratio of the Imports in Puerto Rico in 1997 to that in 2001?
Offer a very short reply. 0.78. What is the ratio of the Imports in Cyprus in 1997 to that in 2002?
Give a very brief answer. 0.89. What is the ratio of the Imports of New Zealand in 1997 to that in 2002?
Ensure brevity in your answer.  0.8. What is the ratio of the Imports of Peru in 1997 to that in 2002?
Ensure brevity in your answer.  1.05. What is the ratio of the Imports in Puerto Rico in 1997 to that in 2002?
Provide a short and direct response. 0.78. What is the ratio of the Imports in Cyprus in 1998 to that in 1999?
Your answer should be very brief. 0.98. What is the ratio of the Imports in New Zealand in 1998 to that in 1999?
Ensure brevity in your answer.  0.9. What is the ratio of the Imports of Peru in 1998 to that in 1999?
Your answer should be very brief. 1.18. What is the ratio of the Imports of Puerto Rico in 1998 to that in 1999?
Your response must be concise. 0.9. What is the ratio of the Imports in Cyprus in 1998 to that in 2000?
Provide a short and direct response. 0.89. What is the ratio of the Imports in New Zealand in 1998 to that in 2000?
Offer a terse response. 0.91. What is the ratio of the Imports of Peru in 1998 to that in 2000?
Give a very brief answer. 1.14. What is the ratio of the Imports of Puerto Rico in 1998 to that in 2000?
Keep it short and to the point. 0.88. What is the ratio of the Imports in Cyprus in 1998 to that in 2001?
Your response must be concise. 0.9. What is the ratio of the Imports in New Zealand in 1998 to that in 2001?
Ensure brevity in your answer.  0.87. What is the ratio of the Imports in Peru in 1998 to that in 2001?
Give a very brief answer. 1.1. What is the ratio of the Imports of Puerto Rico in 1998 to that in 2001?
Provide a short and direct response. 0.82. What is the ratio of the Imports in Cyprus in 1998 to that in 2002?
Your answer should be compact. 0.9. What is the ratio of the Imports in New Zealand in 1998 to that in 2002?
Ensure brevity in your answer.  0.81. What is the ratio of the Imports of Peru in 1998 to that in 2002?
Ensure brevity in your answer.  1.08. What is the ratio of the Imports in Puerto Rico in 1998 to that in 2002?
Keep it short and to the point. 0.82. What is the ratio of the Imports of Cyprus in 1999 to that in 2000?
Offer a terse response. 0.92. What is the ratio of the Imports in New Zealand in 1999 to that in 2000?
Keep it short and to the point. 1.01. What is the ratio of the Imports of Puerto Rico in 1999 to that in 2000?
Provide a succinct answer. 0.97. What is the ratio of the Imports of Cyprus in 1999 to that in 2001?
Provide a succinct answer. 0.92. What is the ratio of the Imports in New Zealand in 1999 to that in 2001?
Offer a very short reply. 0.97. What is the ratio of the Imports in Peru in 1999 to that in 2001?
Your response must be concise. 0.94. What is the ratio of the Imports of Puerto Rico in 1999 to that in 2001?
Your answer should be compact. 0.91. What is the ratio of the Imports in Cyprus in 1999 to that in 2002?
Your answer should be compact. 0.92. What is the ratio of the Imports of New Zealand in 1999 to that in 2002?
Offer a terse response. 0.9. What is the ratio of the Imports of Peru in 1999 to that in 2002?
Your answer should be compact. 0.91. What is the ratio of the Imports of Puerto Rico in 1999 to that in 2002?
Provide a short and direct response. 0.91. What is the ratio of the Imports in Cyprus in 2000 to that in 2001?
Your answer should be compact. 1. What is the ratio of the Imports of Peru in 2000 to that in 2001?
Provide a short and direct response. 0.97. What is the ratio of the Imports of Puerto Rico in 2000 to that in 2001?
Your answer should be very brief. 0.93. What is the ratio of the Imports in Cyprus in 2000 to that in 2002?
Offer a terse response. 1.01. What is the ratio of the Imports in New Zealand in 2000 to that in 2002?
Offer a very short reply. 0.89. What is the ratio of the Imports in Peru in 2000 to that in 2002?
Provide a short and direct response. 0.95. What is the ratio of the Imports in Puerto Rico in 2000 to that in 2002?
Offer a terse response. 0.93. What is the ratio of the Imports in New Zealand in 2001 to that in 2002?
Give a very brief answer. 0.93. What is the ratio of the Imports of Peru in 2001 to that in 2002?
Keep it short and to the point. 0.98. What is the difference between the highest and the second highest Imports in Cyprus?
Ensure brevity in your answer.  1.49e+07. What is the difference between the highest and the second highest Imports in New Zealand?
Your response must be concise. 2.72e+09. What is the difference between the highest and the second highest Imports of Peru?
Keep it short and to the point. 1.05e+09. What is the difference between the highest and the second highest Imports in Puerto Rico?
Offer a very short reply. 5.59e+05. What is the difference between the highest and the lowest Imports in Cyprus?
Ensure brevity in your answer.  1.26e+09. What is the difference between the highest and the lowest Imports of New Zealand?
Make the answer very short. 1.07e+1. What is the difference between the highest and the lowest Imports of Peru?
Offer a very short reply. 7.04e+09. What is the difference between the highest and the lowest Imports in Puerto Rico?
Provide a succinct answer. 2.79e+09. 